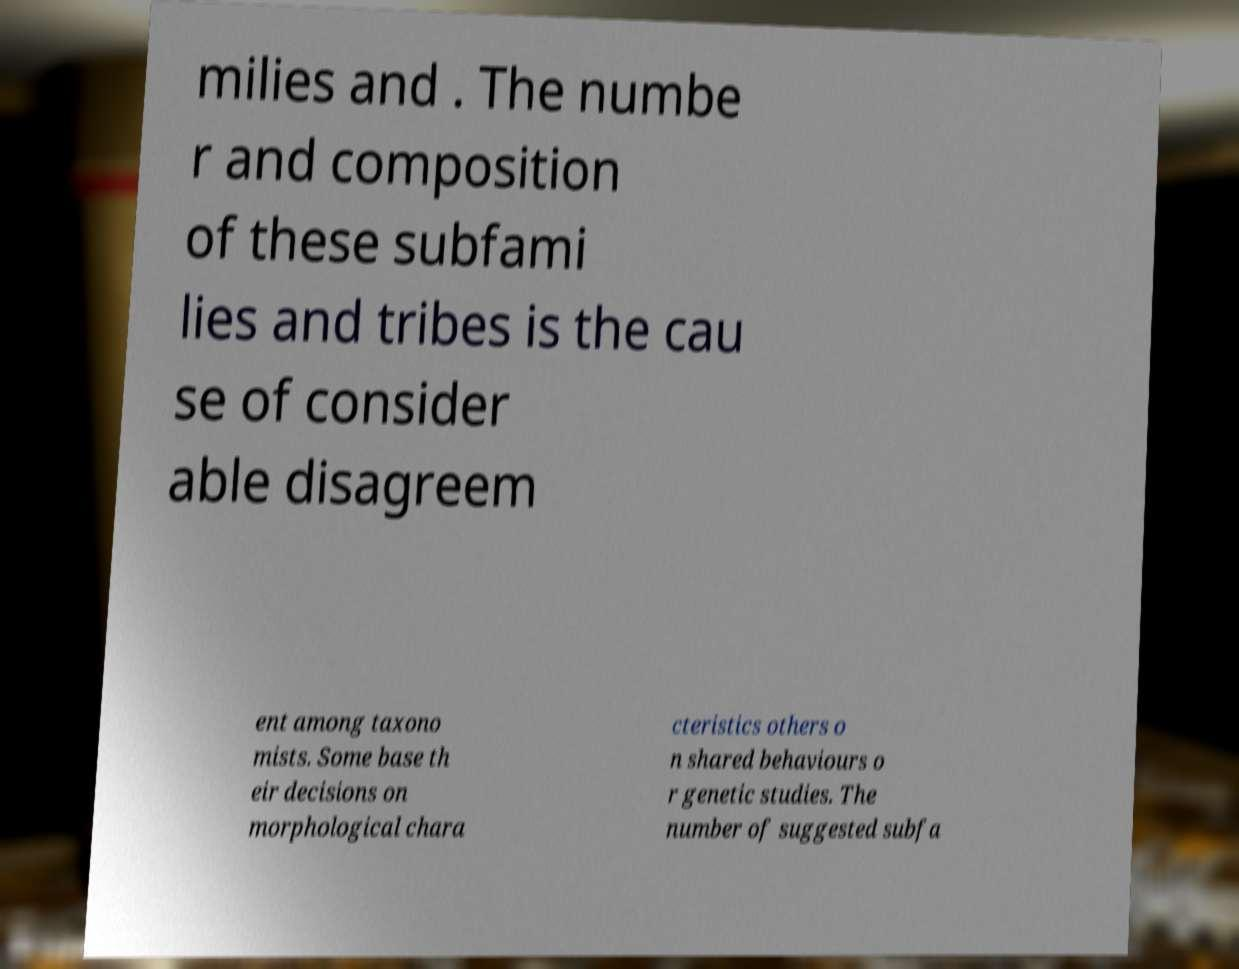Please identify and transcribe the text found in this image. milies and . The numbe r and composition of these subfami lies and tribes is the cau se of consider able disagreem ent among taxono mists. Some base th eir decisions on morphological chara cteristics others o n shared behaviours o r genetic studies. The number of suggested subfa 